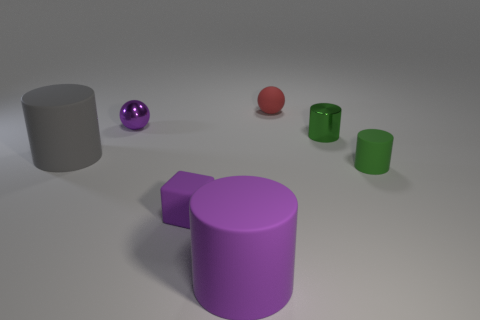Does the object behind the shiny ball have the same color as the matte cylinder on the left side of the small purple ball? The object behind the shiny ball, which appears to be a matte cylinder, is not the same color as the matte cylinder on the left side of the small purple ball. The cylinder behind the shiny ball has a grey color, while the cylinder on the left side of the purple ball is a vibrant green. 